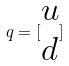Convert formula to latex. <formula><loc_0><loc_0><loc_500><loc_500>q = [ \begin{matrix} u \\ d \end{matrix} ]</formula> 